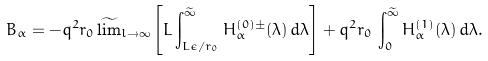<formula> <loc_0><loc_0><loc_500><loc_500>B _ { \alpha } = - q ^ { 2 } r _ { 0 } \, \widetilde { \lim } _ { l \to \infty } \left [ L \int _ { L \epsilon / r _ { 0 } } ^ { \widetilde { \infty } } H _ { \alpha } ^ { ( 0 ) \pm } ( \lambda ) \, d \lambda \right ] + q ^ { 2 } r _ { 0 } \, \int _ { 0 } ^ { \widetilde { \infty } } H _ { \alpha } ^ { ( 1 ) } ( \lambda ) \, d \lambda .</formula> 